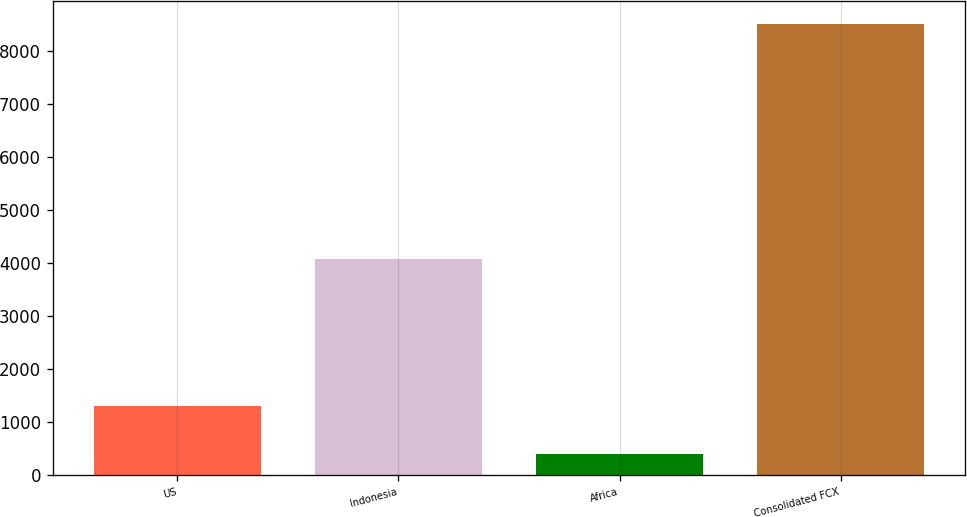Convert chart. <chart><loc_0><loc_0><loc_500><loc_500><bar_chart><fcel>US<fcel>Indonesia<fcel>Africa<fcel>Consolidated FCX<nl><fcel>1307<fcel>4069<fcel>395<fcel>8512<nl></chart> 